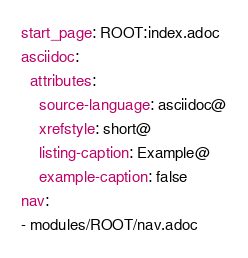<code> <loc_0><loc_0><loc_500><loc_500><_YAML_>start_page: ROOT:index.adoc
asciidoc:
  attributes:
    source-language: asciidoc@
    xrefstyle: short@
    listing-caption: Example@
    example-caption: false
nav:
- modules/ROOT/nav.adoc
</code> 